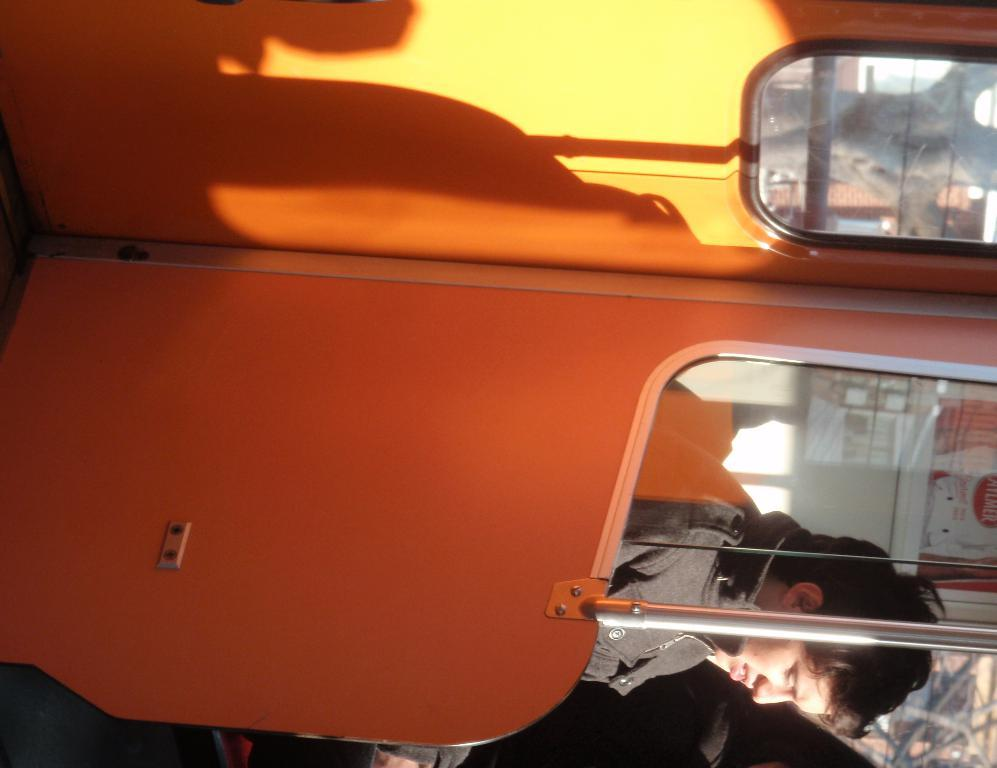What is the person in the image doing? The person is in a vehicle. What objects can be seen inside the vehicle? There is a rod and a glass object in the vehicle. What type of window is present in the vehicle? There is a glass window in the vehicle. What can be seen through the glass window? A poster is visible through the glass window. What type of lettuce is growing in the yard outside the vehicle? There is no yard or lettuce visible in the image; it only shows the interior of the vehicle. 